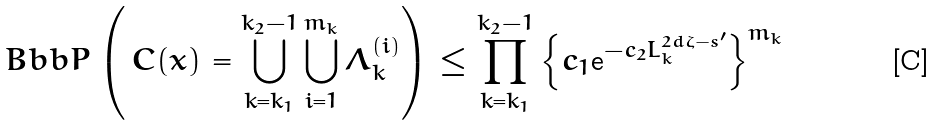<formula> <loc_0><loc_0><loc_500><loc_500>\ B b b P \left ( \, C ( x ) = \bigcup _ { k = k _ { 1 } } ^ { k _ { 2 } - 1 } \bigcup _ { i = 1 } ^ { m _ { k } } \Lambda _ { k } ^ { ( i ) } \right ) \leq \prod _ { k = k _ { 1 } } ^ { k _ { 2 } - 1 } \left \{ c _ { 1 } \text  e^{-c_{2}L_{k}^{2d\zeta-s^{\prime}}} \right \} ^ { m _ { k } }</formula> 